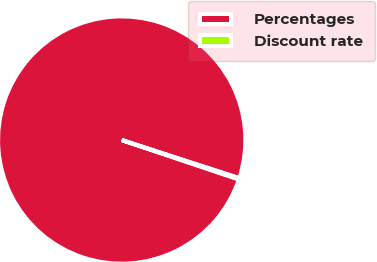Convert chart to OTSL. <chart><loc_0><loc_0><loc_500><loc_500><pie_chart><fcel>Percentages<fcel>Discount rate<nl><fcel>99.82%<fcel>0.18%<nl></chart> 